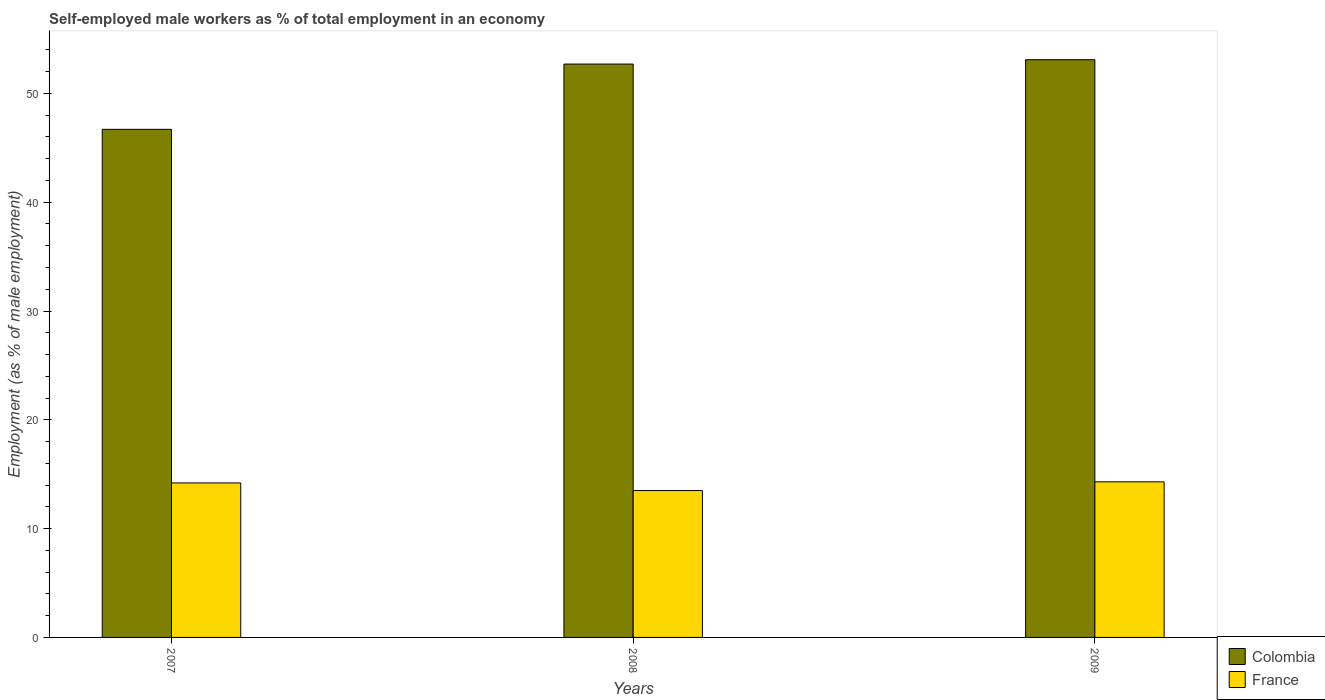How many groups of bars are there?
Make the answer very short. 3. Are the number of bars per tick equal to the number of legend labels?
Your response must be concise. Yes. Are the number of bars on each tick of the X-axis equal?
Provide a succinct answer. Yes. How many bars are there on the 1st tick from the left?
Make the answer very short. 2. What is the label of the 2nd group of bars from the left?
Your response must be concise. 2008. What is the percentage of self-employed male workers in France in 2008?
Make the answer very short. 13.5. Across all years, what is the maximum percentage of self-employed male workers in France?
Offer a very short reply. 14.3. Across all years, what is the minimum percentage of self-employed male workers in Colombia?
Your answer should be compact. 46.7. What is the total percentage of self-employed male workers in Colombia in the graph?
Your answer should be very brief. 152.5. What is the difference between the percentage of self-employed male workers in France in 2007 and that in 2009?
Offer a very short reply. -0.1. What is the difference between the percentage of self-employed male workers in Colombia in 2007 and the percentage of self-employed male workers in France in 2008?
Your answer should be compact. 33.2. What is the average percentage of self-employed male workers in Colombia per year?
Provide a short and direct response. 50.83. In the year 2008, what is the difference between the percentage of self-employed male workers in Colombia and percentage of self-employed male workers in France?
Make the answer very short. 39.2. What is the ratio of the percentage of self-employed male workers in France in 2007 to that in 2009?
Your response must be concise. 0.99. Is the difference between the percentage of self-employed male workers in Colombia in 2007 and 2009 greater than the difference between the percentage of self-employed male workers in France in 2007 and 2009?
Offer a terse response. No. What is the difference between the highest and the second highest percentage of self-employed male workers in Colombia?
Offer a very short reply. 0.4. What is the difference between the highest and the lowest percentage of self-employed male workers in Colombia?
Give a very brief answer. 6.4. Is the sum of the percentage of self-employed male workers in France in 2008 and 2009 greater than the maximum percentage of self-employed male workers in Colombia across all years?
Offer a very short reply. No. How many bars are there?
Your response must be concise. 6. Are all the bars in the graph horizontal?
Offer a very short reply. No. How many years are there in the graph?
Ensure brevity in your answer.  3. Are the values on the major ticks of Y-axis written in scientific E-notation?
Provide a succinct answer. No. Does the graph contain any zero values?
Your response must be concise. No. Where does the legend appear in the graph?
Provide a succinct answer. Bottom right. How many legend labels are there?
Make the answer very short. 2. What is the title of the graph?
Your response must be concise. Self-employed male workers as % of total employment in an economy. Does "Croatia" appear as one of the legend labels in the graph?
Make the answer very short. No. What is the label or title of the Y-axis?
Your response must be concise. Employment (as % of male employment). What is the Employment (as % of male employment) in Colombia in 2007?
Give a very brief answer. 46.7. What is the Employment (as % of male employment) in France in 2007?
Offer a terse response. 14.2. What is the Employment (as % of male employment) in Colombia in 2008?
Your answer should be compact. 52.7. What is the Employment (as % of male employment) in France in 2008?
Your answer should be compact. 13.5. What is the Employment (as % of male employment) of Colombia in 2009?
Ensure brevity in your answer.  53.1. What is the Employment (as % of male employment) of France in 2009?
Your response must be concise. 14.3. Across all years, what is the maximum Employment (as % of male employment) in Colombia?
Provide a short and direct response. 53.1. Across all years, what is the maximum Employment (as % of male employment) of France?
Give a very brief answer. 14.3. Across all years, what is the minimum Employment (as % of male employment) of Colombia?
Your answer should be very brief. 46.7. What is the total Employment (as % of male employment) in Colombia in the graph?
Provide a short and direct response. 152.5. What is the difference between the Employment (as % of male employment) in France in 2007 and that in 2008?
Make the answer very short. 0.7. What is the difference between the Employment (as % of male employment) of Colombia in 2007 and that in 2009?
Provide a succinct answer. -6.4. What is the difference between the Employment (as % of male employment) in France in 2007 and that in 2009?
Keep it short and to the point. -0.1. What is the difference between the Employment (as % of male employment) in Colombia in 2008 and that in 2009?
Your answer should be very brief. -0.4. What is the difference between the Employment (as % of male employment) in Colombia in 2007 and the Employment (as % of male employment) in France in 2008?
Your response must be concise. 33.2. What is the difference between the Employment (as % of male employment) in Colombia in 2007 and the Employment (as % of male employment) in France in 2009?
Keep it short and to the point. 32.4. What is the difference between the Employment (as % of male employment) of Colombia in 2008 and the Employment (as % of male employment) of France in 2009?
Your response must be concise. 38.4. What is the average Employment (as % of male employment) in Colombia per year?
Ensure brevity in your answer.  50.83. What is the average Employment (as % of male employment) of France per year?
Make the answer very short. 14. In the year 2007, what is the difference between the Employment (as % of male employment) in Colombia and Employment (as % of male employment) in France?
Your answer should be very brief. 32.5. In the year 2008, what is the difference between the Employment (as % of male employment) in Colombia and Employment (as % of male employment) in France?
Offer a very short reply. 39.2. In the year 2009, what is the difference between the Employment (as % of male employment) of Colombia and Employment (as % of male employment) of France?
Ensure brevity in your answer.  38.8. What is the ratio of the Employment (as % of male employment) in Colombia in 2007 to that in 2008?
Give a very brief answer. 0.89. What is the ratio of the Employment (as % of male employment) of France in 2007 to that in 2008?
Your answer should be compact. 1.05. What is the ratio of the Employment (as % of male employment) in Colombia in 2007 to that in 2009?
Make the answer very short. 0.88. What is the ratio of the Employment (as % of male employment) of France in 2007 to that in 2009?
Your answer should be very brief. 0.99. What is the ratio of the Employment (as % of male employment) in France in 2008 to that in 2009?
Offer a very short reply. 0.94. What is the difference between the highest and the second highest Employment (as % of male employment) of France?
Provide a short and direct response. 0.1. What is the difference between the highest and the lowest Employment (as % of male employment) in Colombia?
Ensure brevity in your answer.  6.4. What is the difference between the highest and the lowest Employment (as % of male employment) of France?
Offer a very short reply. 0.8. 